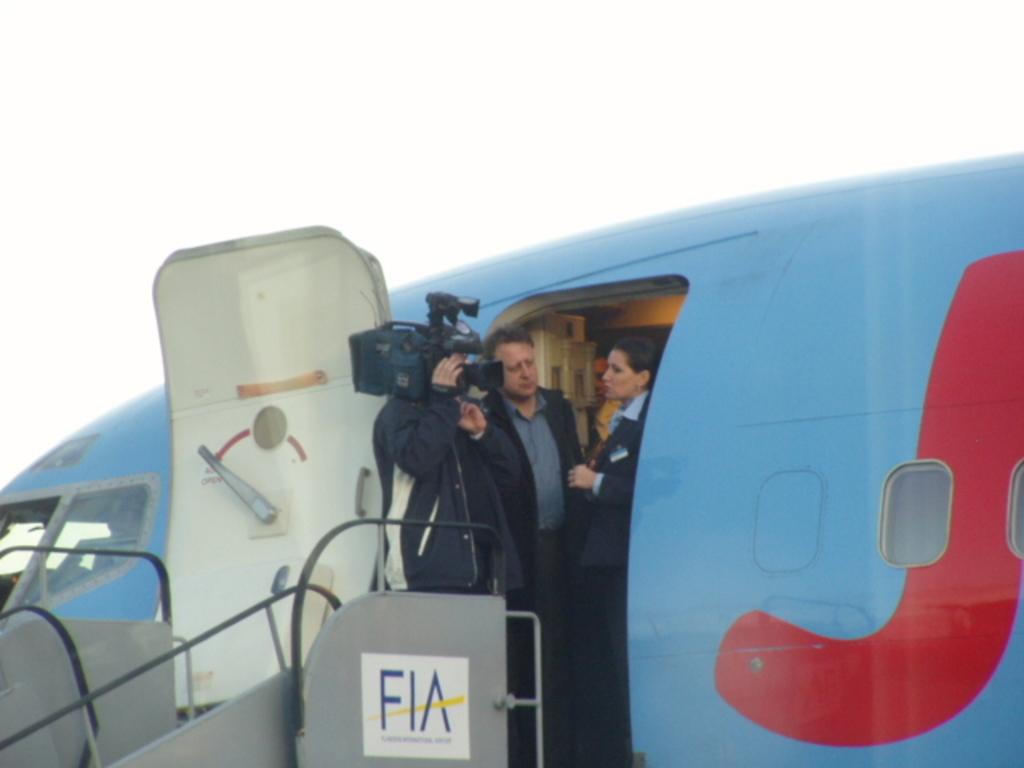What is the 3 letter on the stairs?
Offer a very short reply. Fia. 